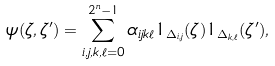<formula> <loc_0><loc_0><loc_500><loc_500>\psi ( \zeta , \zeta ^ { \prime } ) = \sum _ { i , j , k , \ell = 0 } ^ { 2 ^ { n } - 1 } \alpha _ { i j k \ell } 1 _ { \Delta _ { i , j } } ( \zeta ) 1 _ { \Delta _ { k , \ell } } ( \zeta ^ { \prime } ) ,</formula> 